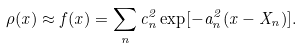<formula> <loc_0><loc_0><loc_500><loc_500>\rho ( x ) \approx f ( x ) = \sum _ { n } c _ { n } ^ { 2 } \exp [ - a _ { n } ^ { 2 } ( x - X _ { n } ) ] .</formula> 